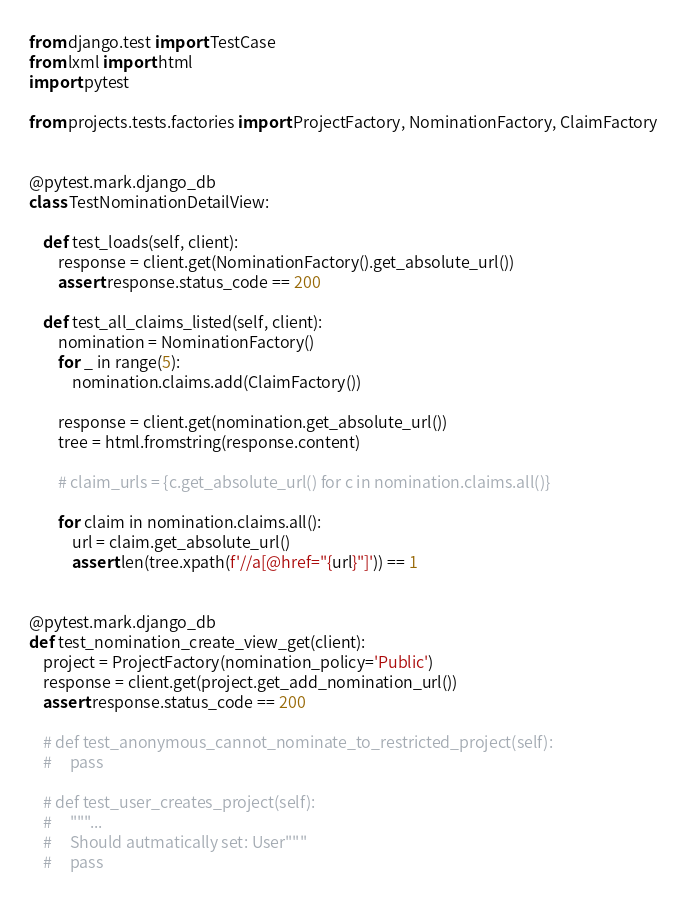<code> <loc_0><loc_0><loc_500><loc_500><_Python_>from django.test import TestCase
from lxml import html
import pytest

from projects.tests.factories import ProjectFactory, NominationFactory, ClaimFactory


@pytest.mark.django_db
class TestNominationDetailView:

    def test_loads(self, client):
        response = client.get(NominationFactory().get_absolute_url())
        assert response.status_code == 200

    def test_all_claims_listed(self, client):
        nomination = NominationFactory()
        for _ in range(5):
            nomination.claims.add(ClaimFactory())

        response = client.get(nomination.get_absolute_url())
        tree = html.fromstring(response.content)

        # claim_urls = {c.get_absolute_url() for c in nomination.claims.all()}

        for claim in nomination.claims.all():
            url = claim.get_absolute_url()
            assert len(tree.xpath(f'//a[@href="{url}"]')) == 1


@pytest.mark.django_db
def test_nomination_create_view_get(client):
    project = ProjectFactory(nomination_policy='Public')
    response = client.get(project.get_add_nomination_url())
    assert response.status_code == 200

    # def test_anonymous_cannot_nominate_to_restricted_project(self):
    #     pass

    # def test_user_creates_project(self):
    #     """...
    #     Should autmatically set: User"""
    #     pass
</code> 